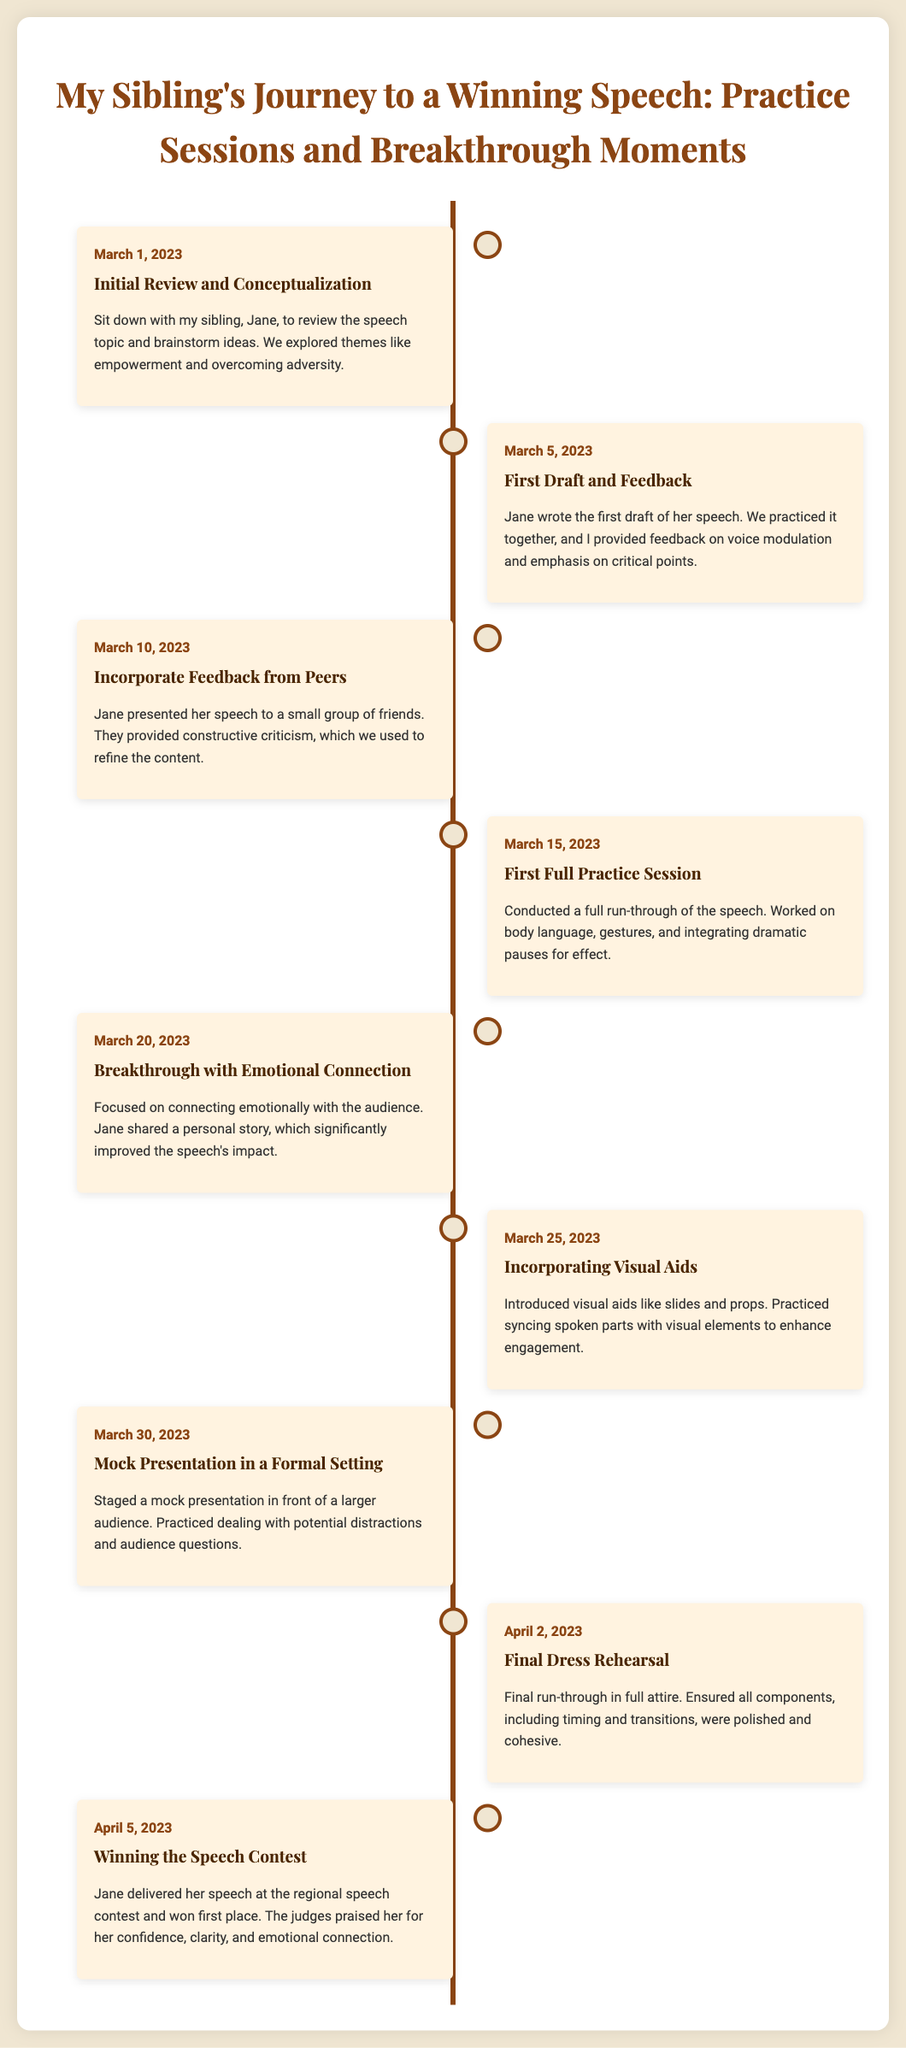what is the title of the document? The title of the document is presented at the top of the infographic, and it describes the subject matter of the timeline.
Answer: My Sibling's Journey to a Winning Speech: Practice Sessions and Breakthrough Moments what date did the final dress rehearsal occur? The final dress rehearsal is marked with a specific date in the timeline, which provides chronological context to the speech practice process.
Answer: April 2, 2023 who is the sibling featured in the speech journey? The document mentions the sibling's name, which is an important detail about the individual involved in the speech preparation.
Answer: Jane how many events are listed in the timeline? The number of events is reflected in the structured layout of the timeline, detailing key moments in the speech preparation process.
Answer: 9 which event focused on emotional connection? This question pertains to identifying a specific event in the timeline that emphasizes an important aspect of delivering a persuasive speech.
Answer: Breakthrough with Emotional Connection what was introduced during the event on March 25, 2023? This event details the incorporation of a particular element that enhances the speech presentation, which is noted in the timeline.
Answer: Visual aids at which event did Jane win first place? The timeline includes a specific event detailing the outcome of the speech contest, highlighting the culmination of the preparation journey.
Answer: Winning the Speech Contest what key skill did Jane work on during the first full practice session? This event captures a particular focus in the preparation that is essential for effective speech delivery, as noted in the timeline.
Answer: Body language who provided feedback during the first draft? The event describes the collaboration during the first draft stage, naming the individual who contributed to the feedback process.
Answer: I (the sibling) 